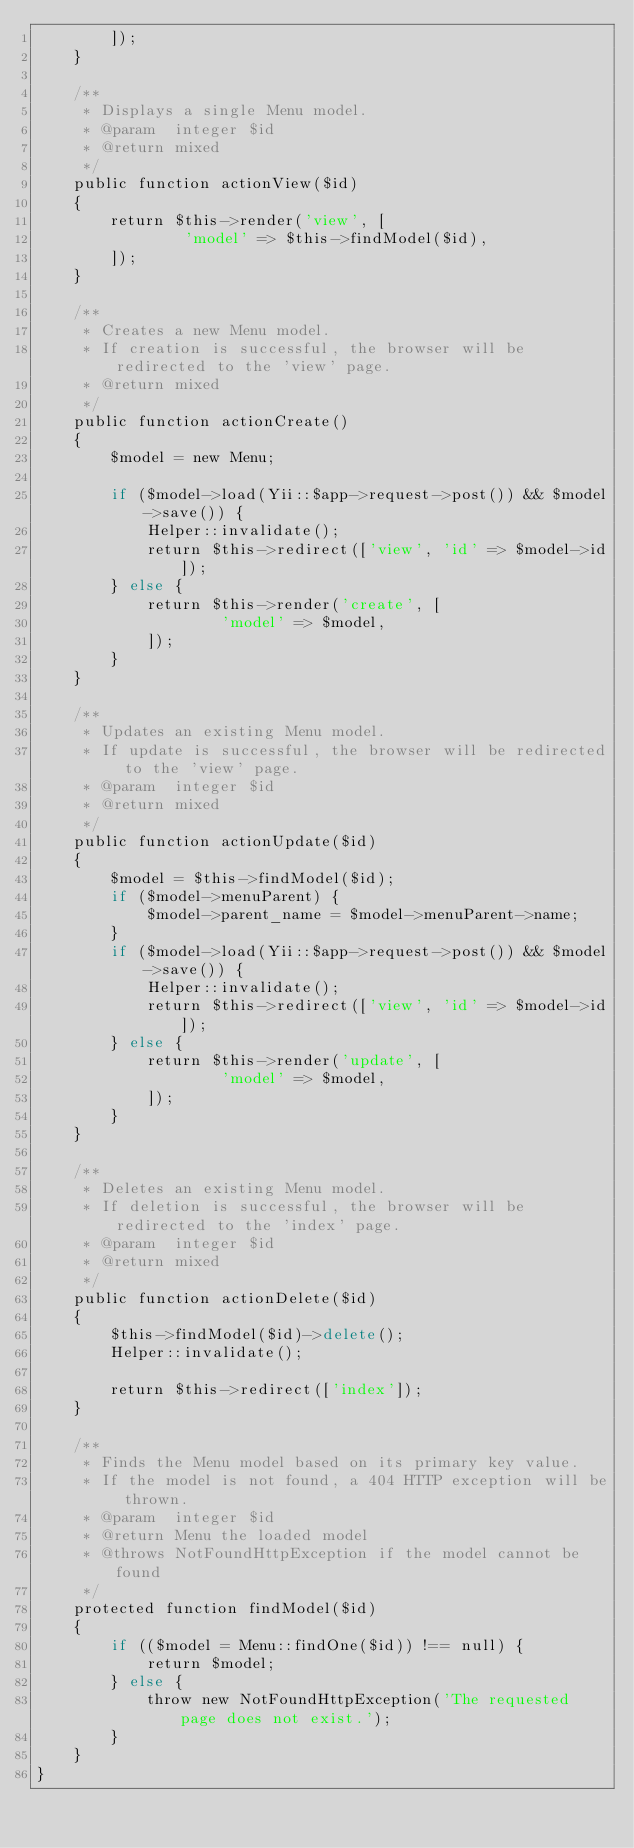<code> <loc_0><loc_0><loc_500><loc_500><_PHP_>        ]);
    }

    /**
     * Displays a single Menu model.
     * @param  integer $id
     * @return mixed
     */
    public function actionView($id)
    {
        return $this->render('view', [
                'model' => $this->findModel($id),
        ]);
    }

    /**
     * Creates a new Menu model.
     * If creation is successful, the browser will be redirected to the 'view' page.
     * @return mixed
     */
    public function actionCreate()
    {
        $model = new Menu;

        if ($model->load(Yii::$app->request->post()) && $model->save()) {
            Helper::invalidate();
            return $this->redirect(['view', 'id' => $model->id]);
        } else {
            return $this->render('create', [
                    'model' => $model,
            ]);
        }
    }

    /**
     * Updates an existing Menu model.
     * If update is successful, the browser will be redirected to the 'view' page.
     * @param  integer $id
     * @return mixed
     */
    public function actionUpdate($id)
    {
        $model = $this->findModel($id);
        if ($model->menuParent) {
            $model->parent_name = $model->menuParent->name;
        }
        if ($model->load(Yii::$app->request->post()) && $model->save()) {
            Helper::invalidate();
            return $this->redirect(['view', 'id' => $model->id]);
        } else {
            return $this->render('update', [
                    'model' => $model,
            ]);
        }
    }

    /**
     * Deletes an existing Menu model.
     * If deletion is successful, the browser will be redirected to the 'index' page.
     * @param  integer $id
     * @return mixed
     */
    public function actionDelete($id)
    {
        $this->findModel($id)->delete();
        Helper::invalidate();

        return $this->redirect(['index']);
    }

    /**
     * Finds the Menu model based on its primary key value.
     * If the model is not found, a 404 HTTP exception will be thrown.
     * @param  integer $id
     * @return Menu the loaded model
     * @throws NotFoundHttpException if the model cannot be found
     */
    protected function findModel($id)
    {
        if (($model = Menu::findOne($id)) !== null) {
            return $model;
        } else {
            throw new NotFoundHttpException('The requested page does not exist.');
        }
    }
}
</code> 